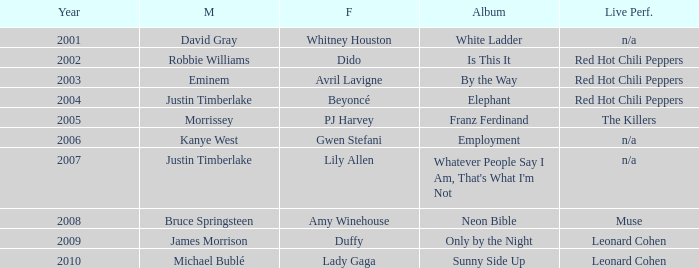Would you mind parsing the complete table? {'header': ['Year', 'M', 'F', 'Album', 'Live Perf.'], 'rows': [['2001', 'David Gray', 'Whitney Houston', 'White Ladder', 'n/a'], ['2002', 'Robbie Williams', 'Dido', 'Is This It', 'Red Hot Chili Peppers'], ['2003', 'Eminem', 'Avril Lavigne', 'By the Way', 'Red Hot Chili Peppers'], ['2004', 'Justin Timberlake', 'Beyoncé', 'Elephant', 'Red Hot Chili Peppers'], ['2005', 'Morrissey', 'PJ Harvey', 'Franz Ferdinand', 'The Killers'], ['2006', 'Kanye West', 'Gwen Stefani', 'Employment', 'n/a'], ['2007', 'Justin Timberlake', 'Lily Allen', "Whatever People Say I Am, That's What I'm Not", 'n/a'], ['2008', 'Bruce Springsteen', 'Amy Winehouse', 'Neon Bible', 'Muse'], ['2009', 'James Morrison', 'Duffy', 'Only by the Night', 'Leonard Cohen'], ['2010', 'Michael Bublé', 'Lady Gaga', 'Sunny Side Up', 'Leonard Cohen']]} Which female artist has an album named elephant? Beyoncé. 